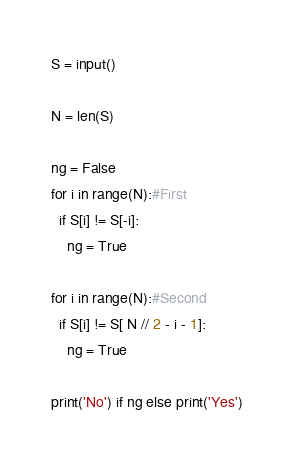Convert code to text. <code><loc_0><loc_0><loc_500><loc_500><_Python_>S = input()

N = len(S)

ng = False
for i in range(N):#First
  if S[i] != S[-i]:
    ng = True

for i in range(N):#Second
  if S[i] != S[ N // 2 - i - 1]:
    ng = True

print('No') if ng else print('Yes')</code> 